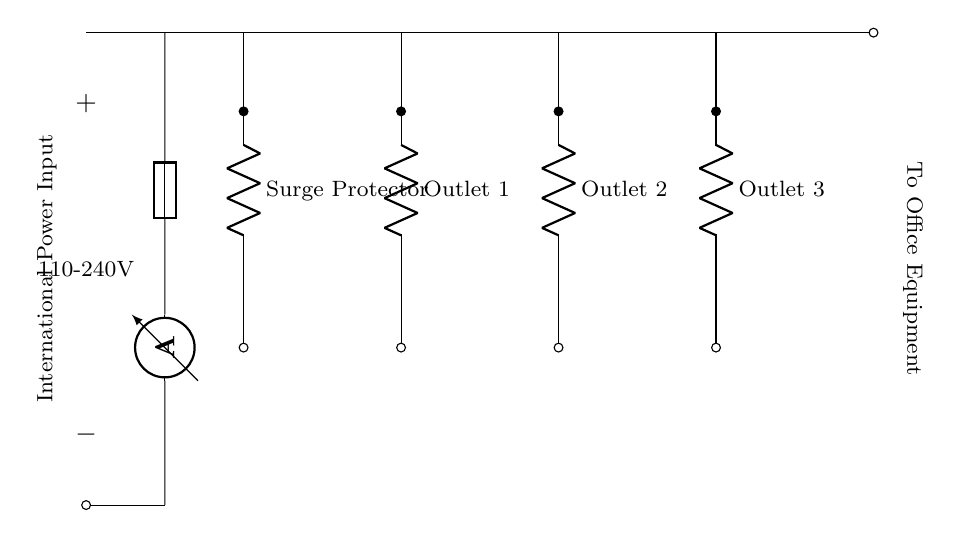What is the voltage range for this power strip? The labeled voltage range, shown in the circuit as 110-240V, indicates the acceptable input voltage for the power strip to function properly.
Answer: 110-240V How many outlets does this power strip have? The circuit diagram directly shows three outlets, each labeled as Outlet 1, Outlet 2, and Outlet 3, indicating the number of individual connections available for office equipment.
Answer: Three What component provides surge protection? The circuit has a component labeled as Surge Protector, which is designed to protect connected devices from voltage spikes and surges, serving as a key element in the overall design.
Answer: Surge Protector What happens to the current after passing through the fuse? The fuse acts as a safety mechanism that interrupts the current flow in the event of an overload, meaning that current will not reach the outlets if the fuse is blown.
Answer: It stops Which direction does the current flow? The current flows from the international power input, through the fuse, to the surge protector, and then to each of the three outlets before reaching the office equipment.
Answer: Rightward What is the purpose of the ammeter in this circuit? The ammeter is used to measure the current flowing through the circuit, providing insights into the current consumption of the connected devices and ensuring they fall within safe operating limits.
Answer: To measure current 